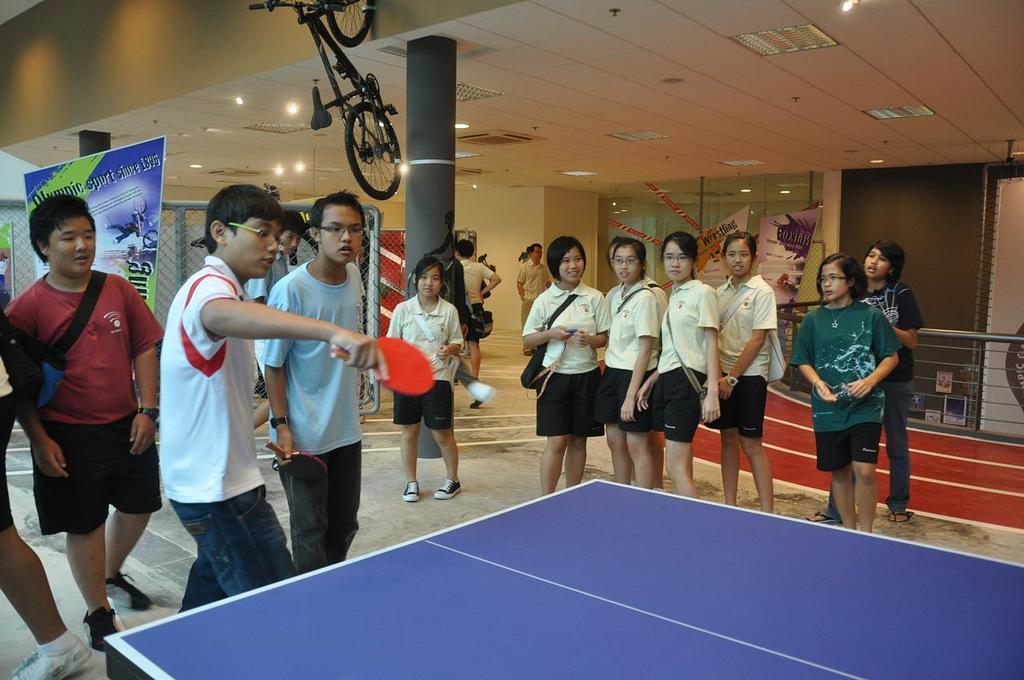How would you summarize this image in a sentence or two? The given image describes about group of peoples, in the left side of the image a boy is playing table tennis and some peoples are watching the game the boy is holding a bat. In the left side we can see some fence,hoardings and on the top we can find a bicycle. 